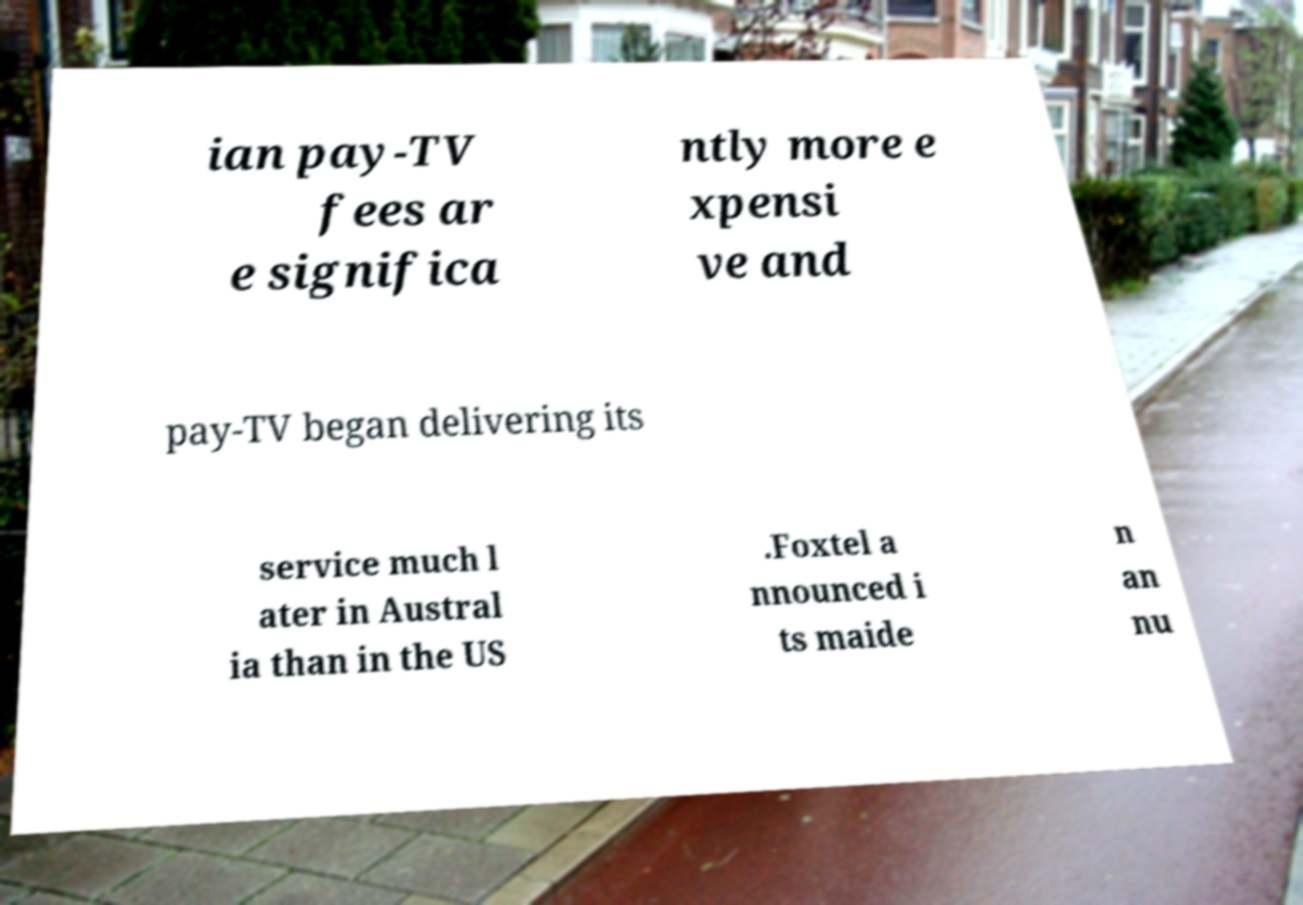Can you read and provide the text displayed in the image?This photo seems to have some interesting text. Can you extract and type it out for me? ian pay-TV fees ar e significa ntly more e xpensi ve and pay-TV began delivering its service much l ater in Austral ia than in the US .Foxtel a nnounced i ts maide n an nu 